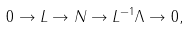<formula> <loc_0><loc_0><loc_500><loc_500>0 \to L \to N \to L ^ { - 1 } \Lambda \to 0 ,</formula> 